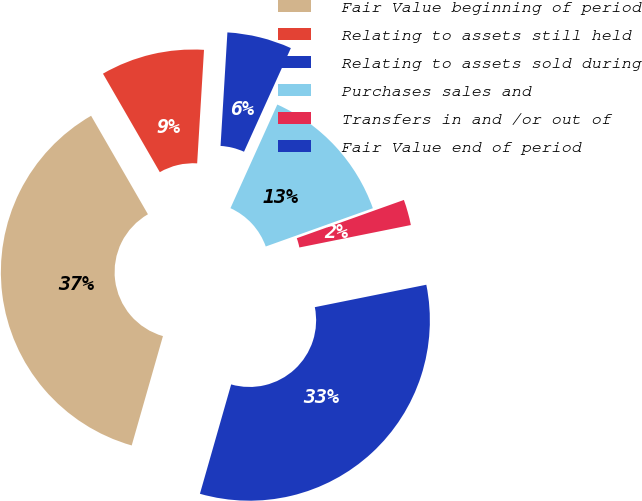Convert chart to OTSL. <chart><loc_0><loc_0><loc_500><loc_500><pie_chart><fcel>Fair Value beginning of period<fcel>Relating to assets still held<fcel>Relating to assets sold during<fcel>Purchases sales and<fcel>Transfers in and /or out of<fcel>Fair Value end of period<nl><fcel>37.24%<fcel>9.29%<fcel>5.8%<fcel>12.78%<fcel>2.3%<fcel>32.59%<nl></chart> 